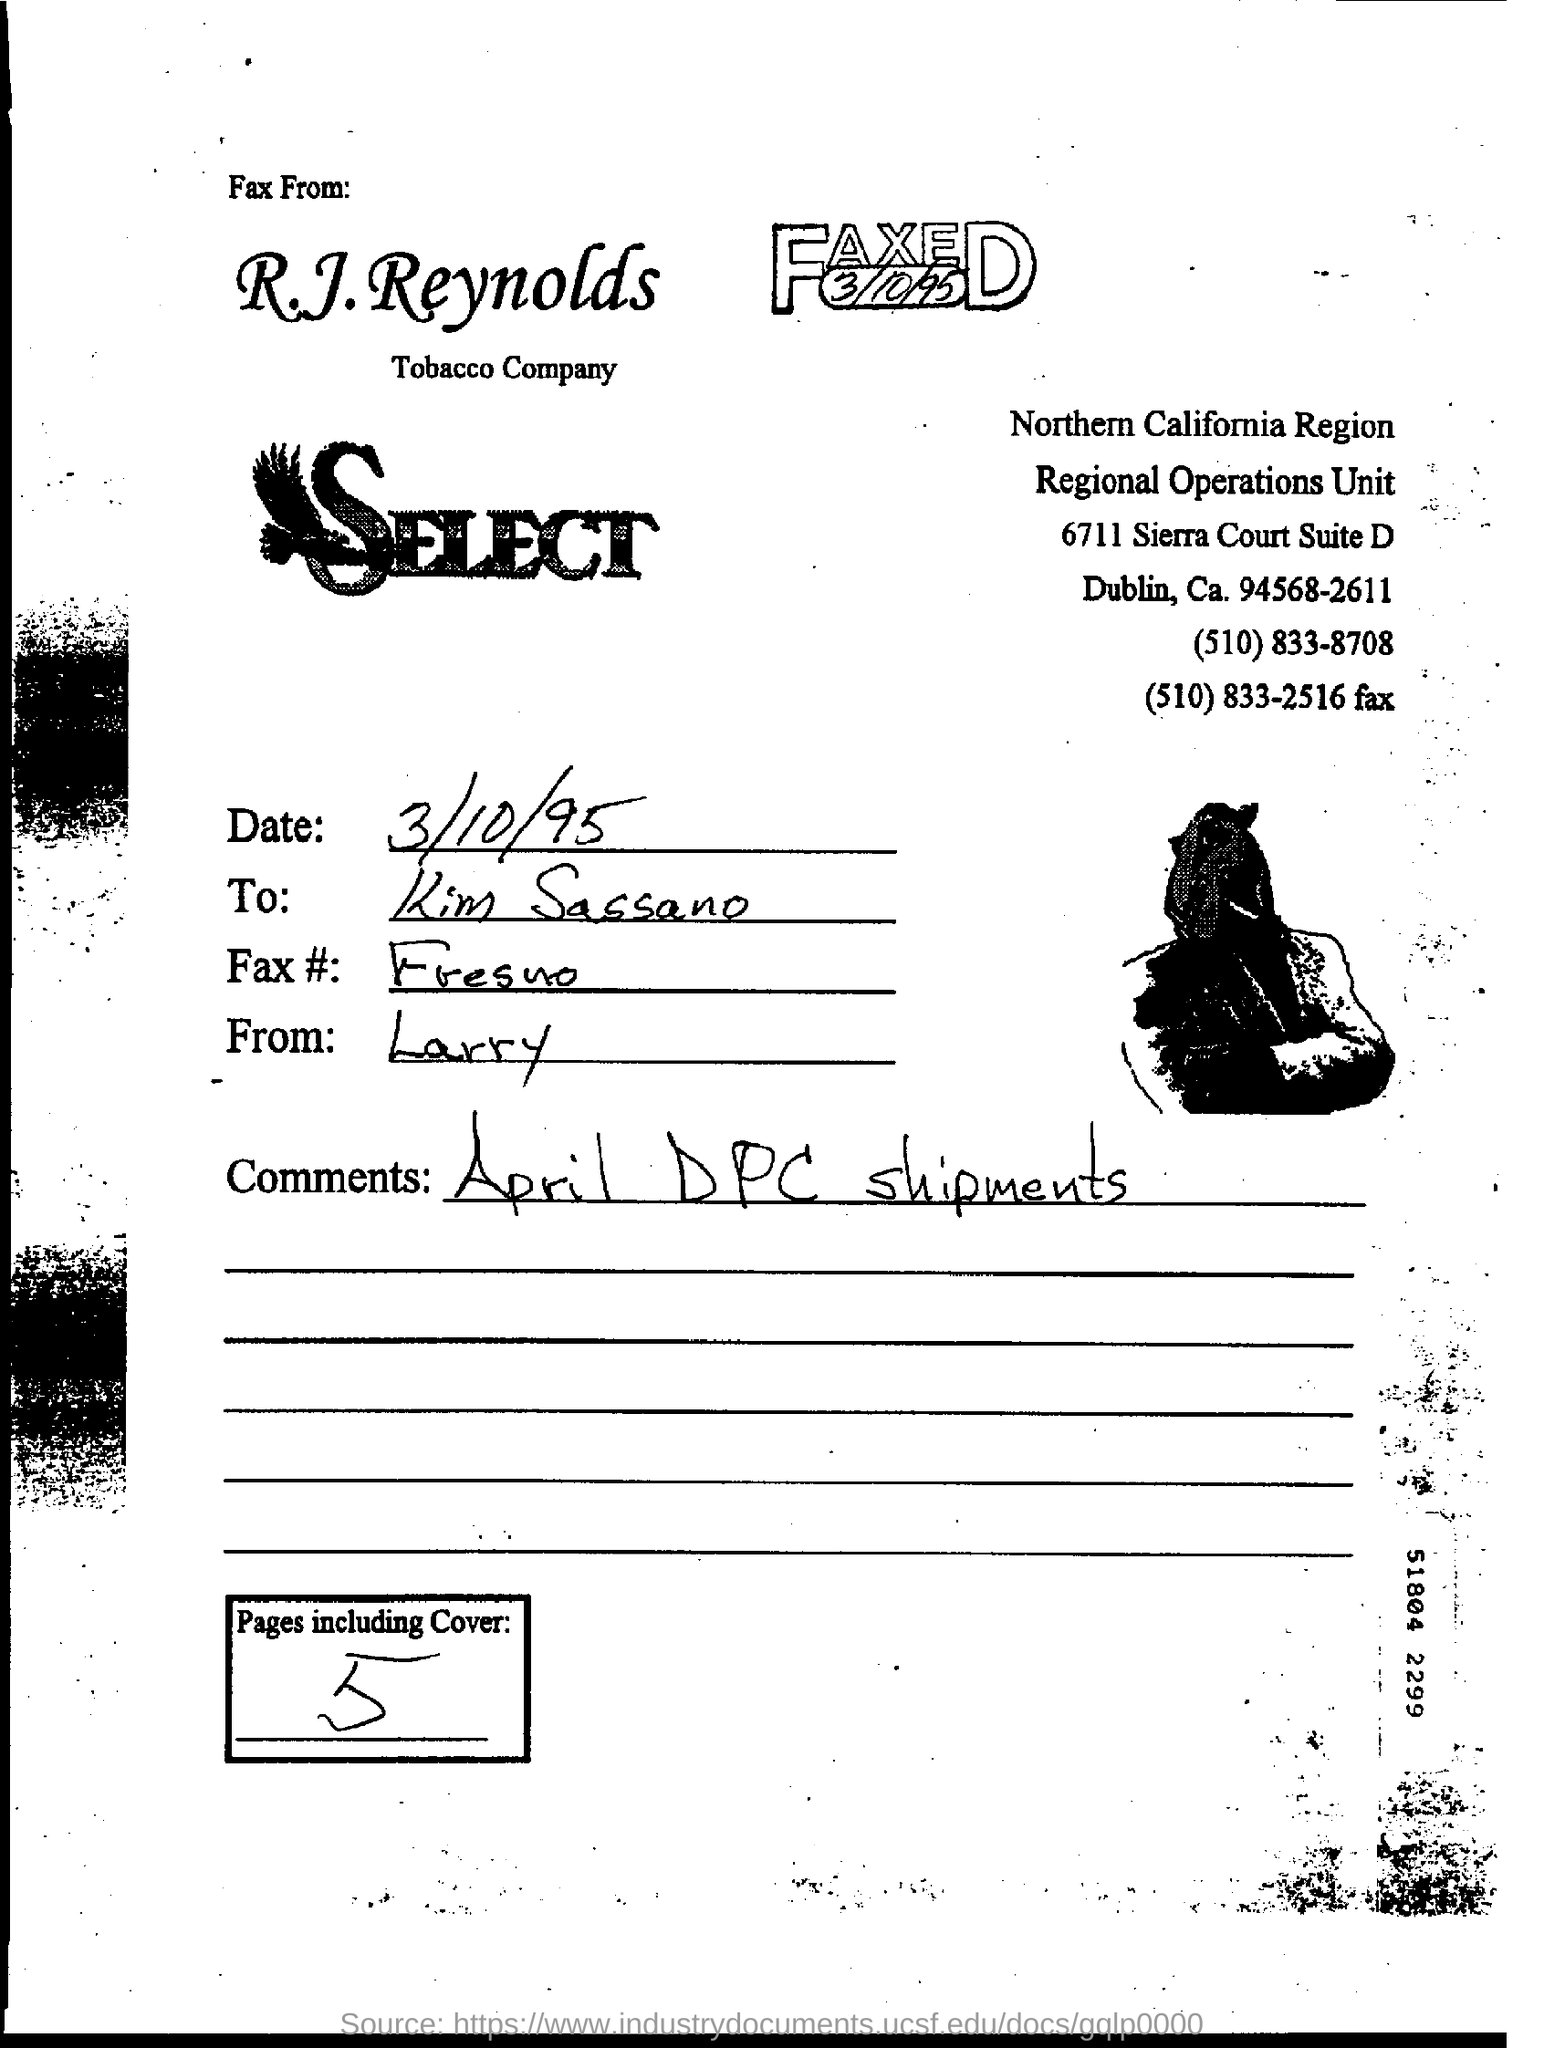What is the Date of the Fax?
Ensure brevity in your answer.  3/10/95. To Whom is this Fax addressed to?
Keep it short and to the point. Kim sassano. What are the Comments in the Fax?
Ensure brevity in your answer.  April DPC Shipments. 